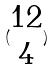<formula> <loc_0><loc_0><loc_500><loc_500>( \begin{matrix} 1 2 \\ 4 \end{matrix} )</formula> 